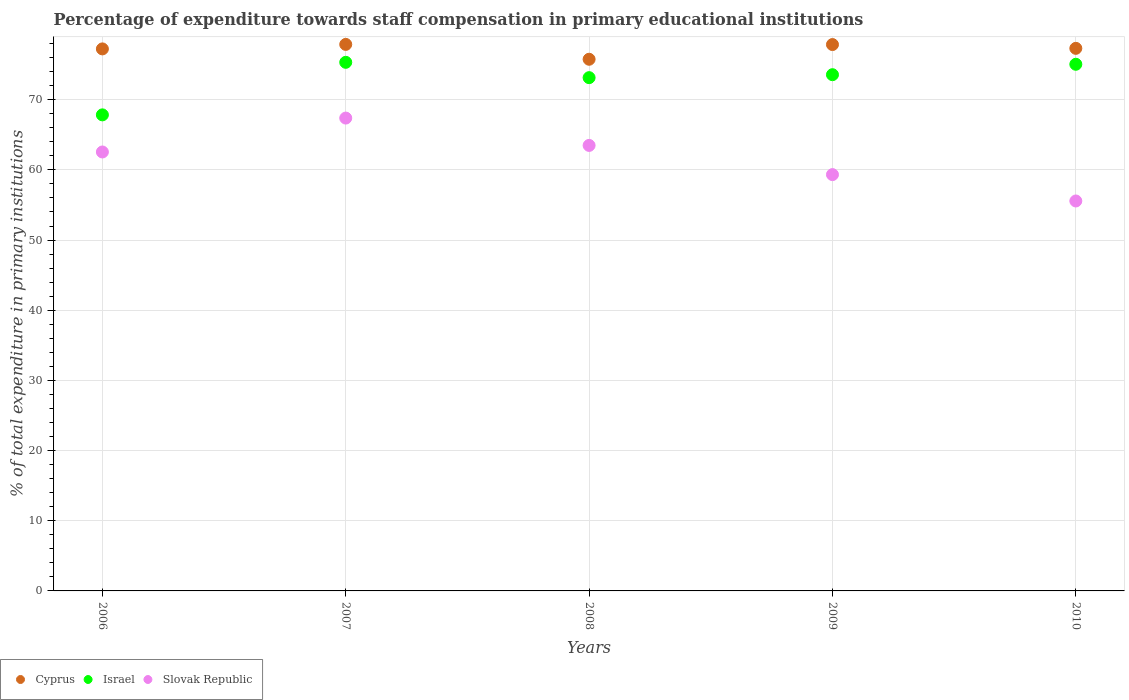What is the percentage of expenditure towards staff compensation in Cyprus in 2006?
Make the answer very short. 77.24. Across all years, what is the maximum percentage of expenditure towards staff compensation in Israel?
Ensure brevity in your answer.  75.32. Across all years, what is the minimum percentage of expenditure towards staff compensation in Israel?
Provide a succinct answer. 67.84. In which year was the percentage of expenditure towards staff compensation in Israel minimum?
Your answer should be compact. 2006. What is the total percentage of expenditure towards staff compensation in Israel in the graph?
Your answer should be compact. 364.91. What is the difference between the percentage of expenditure towards staff compensation in Cyprus in 2007 and that in 2008?
Keep it short and to the point. 2.12. What is the difference between the percentage of expenditure towards staff compensation in Cyprus in 2009 and the percentage of expenditure towards staff compensation in Israel in 2007?
Ensure brevity in your answer.  2.53. What is the average percentage of expenditure towards staff compensation in Slovak Republic per year?
Provide a succinct answer. 61.66. In the year 2010, what is the difference between the percentage of expenditure towards staff compensation in Slovak Republic and percentage of expenditure towards staff compensation in Cyprus?
Make the answer very short. -21.75. In how many years, is the percentage of expenditure towards staff compensation in Israel greater than 76 %?
Make the answer very short. 0. What is the ratio of the percentage of expenditure towards staff compensation in Cyprus in 2008 to that in 2010?
Provide a short and direct response. 0.98. Is the percentage of expenditure towards staff compensation in Israel in 2006 less than that in 2008?
Your response must be concise. Yes. What is the difference between the highest and the second highest percentage of expenditure towards staff compensation in Slovak Republic?
Offer a very short reply. 3.9. What is the difference between the highest and the lowest percentage of expenditure towards staff compensation in Israel?
Provide a short and direct response. 7.49. In how many years, is the percentage of expenditure towards staff compensation in Israel greater than the average percentage of expenditure towards staff compensation in Israel taken over all years?
Your answer should be compact. 4. Is it the case that in every year, the sum of the percentage of expenditure towards staff compensation in Israel and percentage of expenditure towards staff compensation in Cyprus  is greater than the percentage of expenditure towards staff compensation in Slovak Republic?
Ensure brevity in your answer.  Yes. Is the percentage of expenditure towards staff compensation in Slovak Republic strictly greater than the percentage of expenditure towards staff compensation in Israel over the years?
Offer a terse response. No. How many years are there in the graph?
Provide a short and direct response. 5. What is the difference between two consecutive major ticks on the Y-axis?
Offer a terse response. 10. Are the values on the major ticks of Y-axis written in scientific E-notation?
Keep it short and to the point. No. Does the graph contain any zero values?
Your answer should be compact. No. How many legend labels are there?
Your response must be concise. 3. What is the title of the graph?
Your response must be concise. Percentage of expenditure towards staff compensation in primary educational institutions. What is the label or title of the Y-axis?
Keep it short and to the point. % of total expenditure in primary institutions. What is the % of total expenditure in primary institutions in Cyprus in 2006?
Give a very brief answer. 77.24. What is the % of total expenditure in primary institutions of Israel in 2006?
Your answer should be compact. 67.84. What is the % of total expenditure in primary institutions of Slovak Republic in 2006?
Offer a terse response. 62.55. What is the % of total expenditure in primary institutions of Cyprus in 2007?
Your answer should be compact. 77.88. What is the % of total expenditure in primary institutions in Israel in 2007?
Give a very brief answer. 75.32. What is the % of total expenditure in primary institutions in Slovak Republic in 2007?
Your response must be concise. 67.38. What is the % of total expenditure in primary institutions of Cyprus in 2008?
Offer a terse response. 75.76. What is the % of total expenditure in primary institutions in Israel in 2008?
Provide a short and direct response. 73.14. What is the % of total expenditure in primary institutions in Slovak Republic in 2008?
Your answer should be compact. 63.48. What is the % of total expenditure in primary institutions in Cyprus in 2009?
Keep it short and to the point. 77.86. What is the % of total expenditure in primary institutions of Israel in 2009?
Ensure brevity in your answer.  73.56. What is the % of total expenditure in primary institutions of Slovak Republic in 2009?
Offer a terse response. 59.32. What is the % of total expenditure in primary institutions of Cyprus in 2010?
Make the answer very short. 77.32. What is the % of total expenditure in primary institutions of Israel in 2010?
Make the answer very short. 75.05. What is the % of total expenditure in primary institutions of Slovak Republic in 2010?
Provide a succinct answer. 55.57. Across all years, what is the maximum % of total expenditure in primary institutions in Cyprus?
Your answer should be compact. 77.88. Across all years, what is the maximum % of total expenditure in primary institutions of Israel?
Keep it short and to the point. 75.32. Across all years, what is the maximum % of total expenditure in primary institutions of Slovak Republic?
Your response must be concise. 67.38. Across all years, what is the minimum % of total expenditure in primary institutions in Cyprus?
Your answer should be very brief. 75.76. Across all years, what is the minimum % of total expenditure in primary institutions of Israel?
Your answer should be very brief. 67.84. Across all years, what is the minimum % of total expenditure in primary institutions of Slovak Republic?
Ensure brevity in your answer.  55.57. What is the total % of total expenditure in primary institutions in Cyprus in the graph?
Give a very brief answer. 386.04. What is the total % of total expenditure in primary institutions of Israel in the graph?
Ensure brevity in your answer.  364.91. What is the total % of total expenditure in primary institutions of Slovak Republic in the graph?
Your answer should be compact. 308.3. What is the difference between the % of total expenditure in primary institutions of Cyprus in 2006 and that in 2007?
Ensure brevity in your answer.  -0.64. What is the difference between the % of total expenditure in primary institutions of Israel in 2006 and that in 2007?
Offer a very short reply. -7.49. What is the difference between the % of total expenditure in primary institutions in Slovak Republic in 2006 and that in 2007?
Give a very brief answer. -4.83. What is the difference between the % of total expenditure in primary institutions of Cyprus in 2006 and that in 2008?
Offer a very short reply. 1.48. What is the difference between the % of total expenditure in primary institutions of Israel in 2006 and that in 2008?
Provide a short and direct response. -5.3. What is the difference between the % of total expenditure in primary institutions in Slovak Republic in 2006 and that in 2008?
Provide a short and direct response. -0.94. What is the difference between the % of total expenditure in primary institutions in Cyprus in 2006 and that in 2009?
Make the answer very short. -0.62. What is the difference between the % of total expenditure in primary institutions of Israel in 2006 and that in 2009?
Offer a very short reply. -5.72. What is the difference between the % of total expenditure in primary institutions of Slovak Republic in 2006 and that in 2009?
Offer a very short reply. 3.22. What is the difference between the % of total expenditure in primary institutions of Cyprus in 2006 and that in 2010?
Give a very brief answer. -0.08. What is the difference between the % of total expenditure in primary institutions in Israel in 2006 and that in 2010?
Provide a succinct answer. -7.21. What is the difference between the % of total expenditure in primary institutions of Slovak Republic in 2006 and that in 2010?
Offer a very short reply. 6.98. What is the difference between the % of total expenditure in primary institutions in Cyprus in 2007 and that in 2008?
Provide a short and direct response. 2.12. What is the difference between the % of total expenditure in primary institutions in Israel in 2007 and that in 2008?
Offer a terse response. 2.19. What is the difference between the % of total expenditure in primary institutions of Slovak Republic in 2007 and that in 2008?
Provide a succinct answer. 3.9. What is the difference between the % of total expenditure in primary institutions in Cyprus in 2007 and that in 2009?
Offer a terse response. 0.02. What is the difference between the % of total expenditure in primary institutions of Israel in 2007 and that in 2009?
Ensure brevity in your answer.  1.76. What is the difference between the % of total expenditure in primary institutions of Slovak Republic in 2007 and that in 2009?
Offer a very short reply. 8.06. What is the difference between the % of total expenditure in primary institutions in Cyprus in 2007 and that in 2010?
Ensure brevity in your answer.  0.56. What is the difference between the % of total expenditure in primary institutions in Israel in 2007 and that in 2010?
Offer a very short reply. 0.28. What is the difference between the % of total expenditure in primary institutions in Slovak Republic in 2007 and that in 2010?
Your answer should be compact. 11.81. What is the difference between the % of total expenditure in primary institutions in Cyprus in 2008 and that in 2009?
Give a very brief answer. -2.09. What is the difference between the % of total expenditure in primary institutions in Israel in 2008 and that in 2009?
Offer a terse response. -0.42. What is the difference between the % of total expenditure in primary institutions of Slovak Republic in 2008 and that in 2009?
Provide a succinct answer. 4.16. What is the difference between the % of total expenditure in primary institutions of Cyprus in 2008 and that in 2010?
Ensure brevity in your answer.  -1.56. What is the difference between the % of total expenditure in primary institutions in Israel in 2008 and that in 2010?
Your answer should be compact. -1.91. What is the difference between the % of total expenditure in primary institutions of Slovak Republic in 2008 and that in 2010?
Ensure brevity in your answer.  7.92. What is the difference between the % of total expenditure in primary institutions in Cyprus in 2009 and that in 2010?
Make the answer very short. 0.54. What is the difference between the % of total expenditure in primary institutions in Israel in 2009 and that in 2010?
Give a very brief answer. -1.49. What is the difference between the % of total expenditure in primary institutions in Slovak Republic in 2009 and that in 2010?
Keep it short and to the point. 3.76. What is the difference between the % of total expenditure in primary institutions in Cyprus in 2006 and the % of total expenditure in primary institutions in Israel in 2007?
Offer a terse response. 1.91. What is the difference between the % of total expenditure in primary institutions of Cyprus in 2006 and the % of total expenditure in primary institutions of Slovak Republic in 2007?
Keep it short and to the point. 9.86. What is the difference between the % of total expenditure in primary institutions of Israel in 2006 and the % of total expenditure in primary institutions of Slovak Republic in 2007?
Ensure brevity in your answer.  0.46. What is the difference between the % of total expenditure in primary institutions in Cyprus in 2006 and the % of total expenditure in primary institutions in Israel in 2008?
Make the answer very short. 4.1. What is the difference between the % of total expenditure in primary institutions of Cyprus in 2006 and the % of total expenditure in primary institutions of Slovak Republic in 2008?
Your answer should be compact. 13.75. What is the difference between the % of total expenditure in primary institutions in Israel in 2006 and the % of total expenditure in primary institutions in Slovak Republic in 2008?
Your answer should be compact. 4.35. What is the difference between the % of total expenditure in primary institutions in Cyprus in 2006 and the % of total expenditure in primary institutions in Israel in 2009?
Keep it short and to the point. 3.68. What is the difference between the % of total expenditure in primary institutions of Cyprus in 2006 and the % of total expenditure in primary institutions of Slovak Republic in 2009?
Give a very brief answer. 17.91. What is the difference between the % of total expenditure in primary institutions in Israel in 2006 and the % of total expenditure in primary institutions in Slovak Republic in 2009?
Your response must be concise. 8.51. What is the difference between the % of total expenditure in primary institutions of Cyprus in 2006 and the % of total expenditure in primary institutions of Israel in 2010?
Keep it short and to the point. 2.19. What is the difference between the % of total expenditure in primary institutions in Cyprus in 2006 and the % of total expenditure in primary institutions in Slovak Republic in 2010?
Your response must be concise. 21.67. What is the difference between the % of total expenditure in primary institutions in Israel in 2006 and the % of total expenditure in primary institutions in Slovak Republic in 2010?
Make the answer very short. 12.27. What is the difference between the % of total expenditure in primary institutions of Cyprus in 2007 and the % of total expenditure in primary institutions of Israel in 2008?
Your response must be concise. 4.74. What is the difference between the % of total expenditure in primary institutions of Cyprus in 2007 and the % of total expenditure in primary institutions of Slovak Republic in 2008?
Ensure brevity in your answer.  14.39. What is the difference between the % of total expenditure in primary institutions in Israel in 2007 and the % of total expenditure in primary institutions in Slovak Republic in 2008?
Provide a short and direct response. 11.84. What is the difference between the % of total expenditure in primary institutions of Cyprus in 2007 and the % of total expenditure in primary institutions of Israel in 2009?
Make the answer very short. 4.32. What is the difference between the % of total expenditure in primary institutions in Cyprus in 2007 and the % of total expenditure in primary institutions in Slovak Republic in 2009?
Offer a very short reply. 18.55. What is the difference between the % of total expenditure in primary institutions in Israel in 2007 and the % of total expenditure in primary institutions in Slovak Republic in 2009?
Make the answer very short. 16. What is the difference between the % of total expenditure in primary institutions in Cyprus in 2007 and the % of total expenditure in primary institutions in Israel in 2010?
Ensure brevity in your answer.  2.83. What is the difference between the % of total expenditure in primary institutions of Cyprus in 2007 and the % of total expenditure in primary institutions of Slovak Republic in 2010?
Your answer should be compact. 22.31. What is the difference between the % of total expenditure in primary institutions in Israel in 2007 and the % of total expenditure in primary institutions in Slovak Republic in 2010?
Your answer should be compact. 19.76. What is the difference between the % of total expenditure in primary institutions in Cyprus in 2008 and the % of total expenditure in primary institutions in Israel in 2009?
Provide a succinct answer. 2.2. What is the difference between the % of total expenditure in primary institutions in Cyprus in 2008 and the % of total expenditure in primary institutions in Slovak Republic in 2009?
Provide a short and direct response. 16.44. What is the difference between the % of total expenditure in primary institutions of Israel in 2008 and the % of total expenditure in primary institutions of Slovak Republic in 2009?
Your answer should be compact. 13.82. What is the difference between the % of total expenditure in primary institutions of Cyprus in 2008 and the % of total expenditure in primary institutions of Israel in 2010?
Provide a short and direct response. 0.71. What is the difference between the % of total expenditure in primary institutions in Cyprus in 2008 and the % of total expenditure in primary institutions in Slovak Republic in 2010?
Provide a short and direct response. 20.19. What is the difference between the % of total expenditure in primary institutions of Israel in 2008 and the % of total expenditure in primary institutions of Slovak Republic in 2010?
Your answer should be compact. 17.57. What is the difference between the % of total expenditure in primary institutions in Cyprus in 2009 and the % of total expenditure in primary institutions in Israel in 2010?
Offer a terse response. 2.81. What is the difference between the % of total expenditure in primary institutions in Cyprus in 2009 and the % of total expenditure in primary institutions in Slovak Republic in 2010?
Offer a very short reply. 22.29. What is the difference between the % of total expenditure in primary institutions in Israel in 2009 and the % of total expenditure in primary institutions in Slovak Republic in 2010?
Your answer should be very brief. 17.99. What is the average % of total expenditure in primary institutions of Cyprus per year?
Ensure brevity in your answer.  77.21. What is the average % of total expenditure in primary institutions in Israel per year?
Offer a terse response. 72.98. What is the average % of total expenditure in primary institutions in Slovak Republic per year?
Keep it short and to the point. 61.66. In the year 2006, what is the difference between the % of total expenditure in primary institutions of Cyprus and % of total expenditure in primary institutions of Israel?
Keep it short and to the point. 9.4. In the year 2006, what is the difference between the % of total expenditure in primary institutions in Cyprus and % of total expenditure in primary institutions in Slovak Republic?
Your answer should be very brief. 14.69. In the year 2006, what is the difference between the % of total expenditure in primary institutions in Israel and % of total expenditure in primary institutions in Slovak Republic?
Ensure brevity in your answer.  5.29. In the year 2007, what is the difference between the % of total expenditure in primary institutions in Cyprus and % of total expenditure in primary institutions in Israel?
Offer a terse response. 2.55. In the year 2007, what is the difference between the % of total expenditure in primary institutions of Cyprus and % of total expenditure in primary institutions of Slovak Republic?
Give a very brief answer. 10.5. In the year 2007, what is the difference between the % of total expenditure in primary institutions in Israel and % of total expenditure in primary institutions in Slovak Republic?
Provide a short and direct response. 7.94. In the year 2008, what is the difference between the % of total expenditure in primary institutions of Cyprus and % of total expenditure in primary institutions of Israel?
Make the answer very short. 2.62. In the year 2008, what is the difference between the % of total expenditure in primary institutions of Cyprus and % of total expenditure in primary institutions of Slovak Republic?
Ensure brevity in your answer.  12.28. In the year 2008, what is the difference between the % of total expenditure in primary institutions in Israel and % of total expenditure in primary institutions in Slovak Republic?
Give a very brief answer. 9.66. In the year 2009, what is the difference between the % of total expenditure in primary institutions in Cyprus and % of total expenditure in primary institutions in Israel?
Give a very brief answer. 4.29. In the year 2009, what is the difference between the % of total expenditure in primary institutions in Cyprus and % of total expenditure in primary institutions in Slovak Republic?
Provide a short and direct response. 18.53. In the year 2009, what is the difference between the % of total expenditure in primary institutions in Israel and % of total expenditure in primary institutions in Slovak Republic?
Your response must be concise. 14.24. In the year 2010, what is the difference between the % of total expenditure in primary institutions of Cyprus and % of total expenditure in primary institutions of Israel?
Your response must be concise. 2.27. In the year 2010, what is the difference between the % of total expenditure in primary institutions in Cyprus and % of total expenditure in primary institutions in Slovak Republic?
Your answer should be compact. 21.75. In the year 2010, what is the difference between the % of total expenditure in primary institutions in Israel and % of total expenditure in primary institutions in Slovak Republic?
Your response must be concise. 19.48. What is the ratio of the % of total expenditure in primary institutions of Cyprus in 2006 to that in 2007?
Your answer should be compact. 0.99. What is the ratio of the % of total expenditure in primary institutions in Israel in 2006 to that in 2007?
Your response must be concise. 0.9. What is the ratio of the % of total expenditure in primary institutions of Slovak Republic in 2006 to that in 2007?
Provide a succinct answer. 0.93. What is the ratio of the % of total expenditure in primary institutions of Cyprus in 2006 to that in 2008?
Provide a short and direct response. 1.02. What is the ratio of the % of total expenditure in primary institutions of Israel in 2006 to that in 2008?
Keep it short and to the point. 0.93. What is the ratio of the % of total expenditure in primary institutions of Israel in 2006 to that in 2009?
Offer a very short reply. 0.92. What is the ratio of the % of total expenditure in primary institutions in Slovak Republic in 2006 to that in 2009?
Offer a very short reply. 1.05. What is the ratio of the % of total expenditure in primary institutions of Israel in 2006 to that in 2010?
Provide a short and direct response. 0.9. What is the ratio of the % of total expenditure in primary institutions of Slovak Republic in 2006 to that in 2010?
Your answer should be very brief. 1.13. What is the ratio of the % of total expenditure in primary institutions in Cyprus in 2007 to that in 2008?
Offer a very short reply. 1.03. What is the ratio of the % of total expenditure in primary institutions of Israel in 2007 to that in 2008?
Make the answer very short. 1.03. What is the ratio of the % of total expenditure in primary institutions in Slovak Republic in 2007 to that in 2008?
Provide a succinct answer. 1.06. What is the ratio of the % of total expenditure in primary institutions in Slovak Republic in 2007 to that in 2009?
Provide a succinct answer. 1.14. What is the ratio of the % of total expenditure in primary institutions in Cyprus in 2007 to that in 2010?
Offer a terse response. 1.01. What is the ratio of the % of total expenditure in primary institutions in Israel in 2007 to that in 2010?
Keep it short and to the point. 1. What is the ratio of the % of total expenditure in primary institutions of Slovak Republic in 2007 to that in 2010?
Your answer should be very brief. 1.21. What is the ratio of the % of total expenditure in primary institutions in Cyprus in 2008 to that in 2009?
Your answer should be very brief. 0.97. What is the ratio of the % of total expenditure in primary institutions in Slovak Republic in 2008 to that in 2009?
Provide a short and direct response. 1.07. What is the ratio of the % of total expenditure in primary institutions of Cyprus in 2008 to that in 2010?
Your answer should be very brief. 0.98. What is the ratio of the % of total expenditure in primary institutions in Israel in 2008 to that in 2010?
Ensure brevity in your answer.  0.97. What is the ratio of the % of total expenditure in primary institutions in Slovak Republic in 2008 to that in 2010?
Your answer should be compact. 1.14. What is the ratio of the % of total expenditure in primary institutions of Cyprus in 2009 to that in 2010?
Keep it short and to the point. 1.01. What is the ratio of the % of total expenditure in primary institutions in Israel in 2009 to that in 2010?
Keep it short and to the point. 0.98. What is the ratio of the % of total expenditure in primary institutions in Slovak Republic in 2009 to that in 2010?
Your answer should be compact. 1.07. What is the difference between the highest and the second highest % of total expenditure in primary institutions of Cyprus?
Offer a very short reply. 0.02. What is the difference between the highest and the second highest % of total expenditure in primary institutions of Israel?
Keep it short and to the point. 0.28. What is the difference between the highest and the second highest % of total expenditure in primary institutions of Slovak Republic?
Give a very brief answer. 3.9. What is the difference between the highest and the lowest % of total expenditure in primary institutions in Cyprus?
Your answer should be very brief. 2.12. What is the difference between the highest and the lowest % of total expenditure in primary institutions of Israel?
Offer a terse response. 7.49. What is the difference between the highest and the lowest % of total expenditure in primary institutions of Slovak Republic?
Give a very brief answer. 11.81. 